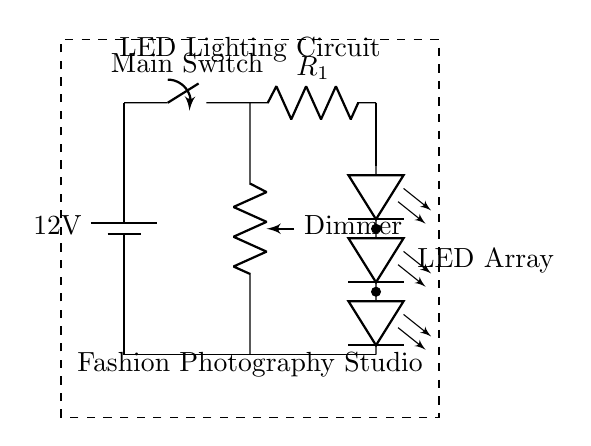What type of components are used in this circuit? The circuit contains a battery, a switch, a resistor, a potentiometer, and LEDs, which are all standard components in an LED lighting circuit.
Answer: battery, switch, resistor, potentiometer, LEDs What is the purpose of the potentiometer in this circuit? The potentiometer acts as a dimmer, allowing the user to adjust the brightness of the LED lights in the studio.
Answer: dimmer What is the voltage of the power supply? The voltage of the power supply is labeled as twelve volts, which means that is the potential difference provided to the circuit components.
Answer: twelve volts How are the LEDs arranged in this circuit? The LEDs are arranged in a series connection, as indicated by the way they are linked one after the other along the circuit path.
Answer: series What would happen if the current limiting resistor were removed from the circuit? Without the current limiting resistor, the LEDs might receive excessive current, leading to overheating and potential damage to the LEDs.
Answer: damage to LEDs How does the switch affect the functionality of the circuit? The switch controls the flow of electricity in the circuit; when it is opened, it interrupts the current, turning off the LED lights.
Answer: controls current flow 